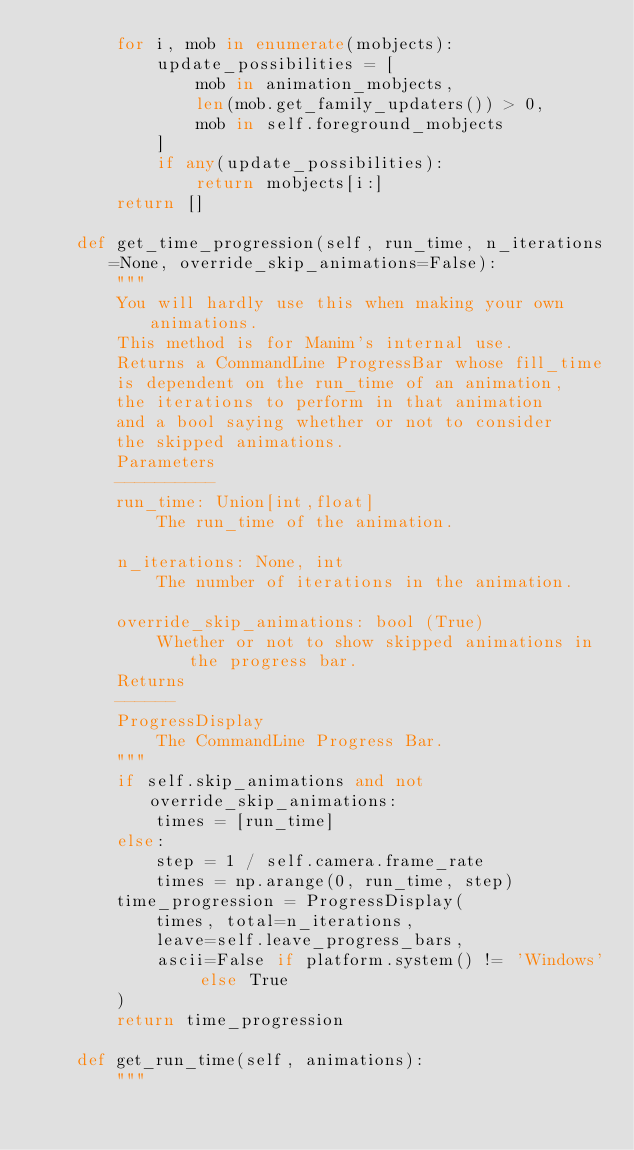<code> <loc_0><loc_0><loc_500><loc_500><_Python_>        for i, mob in enumerate(mobjects):
            update_possibilities = [
                mob in animation_mobjects,
                len(mob.get_family_updaters()) > 0,
                mob in self.foreground_mobjects
            ]
            if any(update_possibilities):
                return mobjects[i:]
        return []

    def get_time_progression(self, run_time, n_iterations=None, override_skip_animations=False):
        """
        You will hardly use this when making your own animations.
        This method is for Manim's internal use.
        Returns a CommandLine ProgressBar whose fill_time
        is dependent on the run_time of an animation, 
        the iterations to perform in that animation
        and a bool saying whether or not to consider
        the skipped animations.
        Parameters
        ----------
        run_time: Union[int,float]
            The run_time of the animation.
        
        n_iterations: None, int
            The number of iterations in the animation.
        
        override_skip_animations: bool (True)
            Whether or not to show skipped animations in the progress bar.
        Returns
        ------
        ProgressDisplay
            The CommandLine Progress Bar.
        """
        if self.skip_animations and not override_skip_animations:
            times = [run_time]
        else:
            step = 1 / self.camera.frame_rate
            times = np.arange(0, run_time, step)
        time_progression = ProgressDisplay(
            times, total=n_iterations,
            leave=self.leave_progress_bars,
            ascii=False if platform.system() != 'Windows' else True
        )
        return time_progression

    def get_run_time(self, animations):
        """</code> 